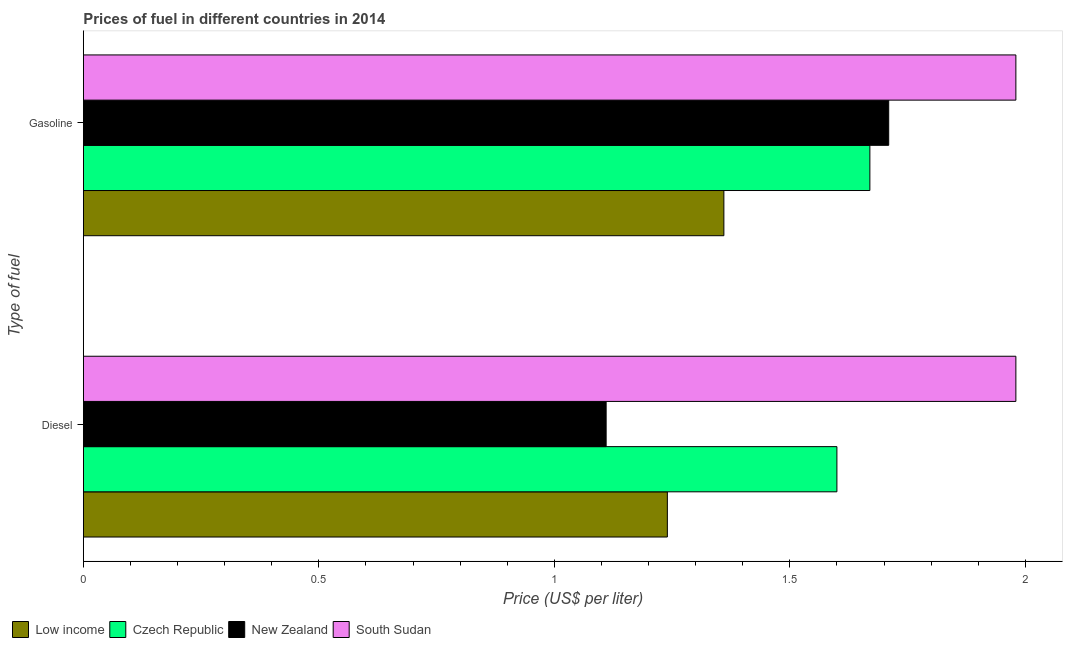How many different coloured bars are there?
Your answer should be very brief. 4. How many groups of bars are there?
Your answer should be very brief. 2. Are the number of bars per tick equal to the number of legend labels?
Your answer should be compact. Yes. How many bars are there on the 2nd tick from the top?
Provide a succinct answer. 4. What is the label of the 1st group of bars from the top?
Make the answer very short. Gasoline. What is the diesel price in New Zealand?
Ensure brevity in your answer.  1.11. Across all countries, what is the maximum diesel price?
Provide a succinct answer. 1.98. Across all countries, what is the minimum gasoline price?
Give a very brief answer. 1.36. In which country was the diesel price maximum?
Your answer should be compact. South Sudan. In which country was the diesel price minimum?
Ensure brevity in your answer.  New Zealand. What is the total diesel price in the graph?
Make the answer very short. 5.93. What is the difference between the diesel price in New Zealand and that in Low income?
Offer a very short reply. -0.13. What is the difference between the diesel price in New Zealand and the gasoline price in South Sudan?
Ensure brevity in your answer.  -0.87. What is the average diesel price per country?
Ensure brevity in your answer.  1.48. What is the difference between the gasoline price and diesel price in New Zealand?
Ensure brevity in your answer.  0.6. In how many countries, is the gasoline price greater than 0.30000000000000004 US$ per litre?
Your answer should be very brief. 4. What is the ratio of the diesel price in South Sudan to that in Low income?
Your answer should be compact. 1.6. Is the gasoline price in Low income less than that in South Sudan?
Your answer should be compact. Yes. What does the 2nd bar from the top in Diesel represents?
Keep it short and to the point. New Zealand. What does the 4th bar from the bottom in Diesel represents?
Your answer should be compact. South Sudan. Are all the bars in the graph horizontal?
Provide a succinct answer. Yes. How many countries are there in the graph?
Your answer should be very brief. 4. What is the difference between two consecutive major ticks on the X-axis?
Give a very brief answer. 0.5. Are the values on the major ticks of X-axis written in scientific E-notation?
Provide a short and direct response. No. Does the graph contain any zero values?
Ensure brevity in your answer.  No. How are the legend labels stacked?
Keep it short and to the point. Horizontal. What is the title of the graph?
Provide a short and direct response. Prices of fuel in different countries in 2014. What is the label or title of the X-axis?
Offer a very short reply. Price (US$ per liter). What is the label or title of the Y-axis?
Give a very brief answer. Type of fuel. What is the Price (US$ per liter) of Low income in Diesel?
Your response must be concise. 1.24. What is the Price (US$ per liter) of Czech Republic in Diesel?
Make the answer very short. 1.6. What is the Price (US$ per liter) in New Zealand in Diesel?
Your answer should be very brief. 1.11. What is the Price (US$ per liter) of South Sudan in Diesel?
Your response must be concise. 1.98. What is the Price (US$ per liter) in Low income in Gasoline?
Ensure brevity in your answer.  1.36. What is the Price (US$ per liter) of Czech Republic in Gasoline?
Your answer should be compact. 1.67. What is the Price (US$ per liter) in New Zealand in Gasoline?
Make the answer very short. 1.71. What is the Price (US$ per liter) in South Sudan in Gasoline?
Your answer should be very brief. 1.98. Across all Type of fuel, what is the maximum Price (US$ per liter) in Low income?
Make the answer very short. 1.36. Across all Type of fuel, what is the maximum Price (US$ per liter) of Czech Republic?
Make the answer very short. 1.67. Across all Type of fuel, what is the maximum Price (US$ per liter) of New Zealand?
Keep it short and to the point. 1.71. Across all Type of fuel, what is the maximum Price (US$ per liter) in South Sudan?
Make the answer very short. 1.98. Across all Type of fuel, what is the minimum Price (US$ per liter) of Low income?
Offer a terse response. 1.24. Across all Type of fuel, what is the minimum Price (US$ per liter) in New Zealand?
Provide a short and direct response. 1.11. Across all Type of fuel, what is the minimum Price (US$ per liter) of South Sudan?
Your response must be concise. 1.98. What is the total Price (US$ per liter) in Low income in the graph?
Offer a very short reply. 2.6. What is the total Price (US$ per liter) of Czech Republic in the graph?
Offer a terse response. 3.27. What is the total Price (US$ per liter) of New Zealand in the graph?
Your answer should be compact. 2.82. What is the total Price (US$ per liter) of South Sudan in the graph?
Offer a terse response. 3.96. What is the difference between the Price (US$ per liter) of Low income in Diesel and that in Gasoline?
Provide a succinct answer. -0.12. What is the difference between the Price (US$ per liter) of Czech Republic in Diesel and that in Gasoline?
Your answer should be very brief. -0.07. What is the difference between the Price (US$ per liter) of Low income in Diesel and the Price (US$ per liter) of Czech Republic in Gasoline?
Your answer should be compact. -0.43. What is the difference between the Price (US$ per liter) in Low income in Diesel and the Price (US$ per liter) in New Zealand in Gasoline?
Ensure brevity in your answer.  -0.47. What is the difference between the Price (US$ per liter) in Low income in Diesel and the Price (US$ per liter) in South Sudan in Gasoline?
Keep it short and to the point. -0.74. What is the difference between the Price (US$ per liter) of Czech Republic in Diesel and the Price (US$ per liter) of New Zealand in Gasoline?
Your answer should be very brief. -0.11. What is the difference between the Price (US$ per liter) of Czech Republic in Diesel and the Price (US$ per liter) of South Sudan in Gasoline?
Provide a short and direct response. -0.38. What is the difference between the Price (US$ per liter) of New Zealand in Diesel and the Price (US$ per liter) of South Sudan in Gasoline?
Your answer should be compact. -0.87. What is the average Price (US$ per liter) in Low income per Type of fuel?
Give a very brief answer. 1.3. What is the average Price (US$ per liter) of Czech Republic per Type of fuel?
Give a very brief answer. 1.64. What is the average Price (US$ per liter) of New Zealand per Type of fuel?
Your answer should be compact. 1.41. What is the average Price (US$ per liter) in South Sudan per Type of fuel?
Your answer should be very brief. 1.98. What is the difference between the Price (US$ per liter) of Low income and Price (US$ per liter) of Czech Republic in Diesel?
Provide a short and direct response. -0.36. What is the difference between the Price (US$ per liter) in Low income and Price (US$ per liter) in New Zealand in Diesel?
Your answer should be compact. 0.13. What is the difference between the Price (US$ per liter) in Low income and Price (US$ per liter) in South Sudan in Diesel?
Ensure brevity in your answer.  -0.74. What is the difference between the Price (US$ per liter) in Czech Republic and Price (US$ per liter) in New Zealand in Diesel?
Offer a terse response. 0.49. What is the difference between the Price (US$ per liter) of Czech Republic and Price (US$ per liter) of South Sudan in Diesel?
Provide a succinct answer. -0.38. What is the difference between the Price (US$ per liter) of New Zealand and Price (US$ per liter) of South Sudan in Diesel?
Offer a terse response. -0.87. What is the difference between the Price (US$ per liter) in Low income and Price (US$ per liter) in Czech Republic in Gasoline?
Make the answer very short. -0.31. What is the difference between the Price (US$ per liter) in Low income and Price (US$ per liter) in New Zealand in Gasoline?
Make the answer very short. -0.35. What is the difference between the Price (US$ per liter) of Low income and Price (US$ per liter) of South Sudan in Gasoline?
Offer a terse response. -0.62. What is the difference between the Price (US$ per liter) of Czech Republic and Price (US$ per liter) of New Zealand in Gasoline?
Keep it short and to the point. -0.04. What is the difference between the Price (US$ per liter) of Czech Republic and Price (US$ per liter) of South Sudan in Gasoline?
Keep it short and to the point. -0.31. What is the difference between the Price (US$ per liter) of New Zealand and Price (US$ per liter) of South Sudan in Gasoline?
Give a very brief answer. -0.27. What is the ratio of the Price (US$ per liter) in Low income in Diesel to that in Gasoline?
Your answer should be compact. 0.91. What is the ratio of the Price (US$ per liter) in Czech Republic in Diesel to that in Gasoline?
Provide a succinct answer. 0.96. What is the ratio of the Price (US$ per liter) of New Zealand in Diesel to that in Gasoline?
Provide a succinct answer. 0.65. What is the ratio of the Price (US$ per liter) of South Sudan in Diesel to that in Gasoline?
Ensure brevity in your answer.  1. What is the difference between the highest and the second highest Price (US$ per liter) in Low income?
Offer a very short reply. 0.12. What is the difference between the highest and the second highest Price (US$ per liter) in Czech Republic?
Ensure brevity in your answer.  0.07. What is the difference between the highest and the lowest Price (US$ per liter) of Low income?
Provide a succinct answer. 0.12. What is the difference between the highest and the lowest Price (US$ per liter) of Czech Republic?
Offer a terse response. 0.07. What is the difference between the highest and the lowest Price (US$ per liter) in New Zealand?
Provide a short and direct response. 0.6. What is the difference between the highest and the lowest Price (US$ per liter) of South Sudan?
Ensure brevity in your answer.  0. 